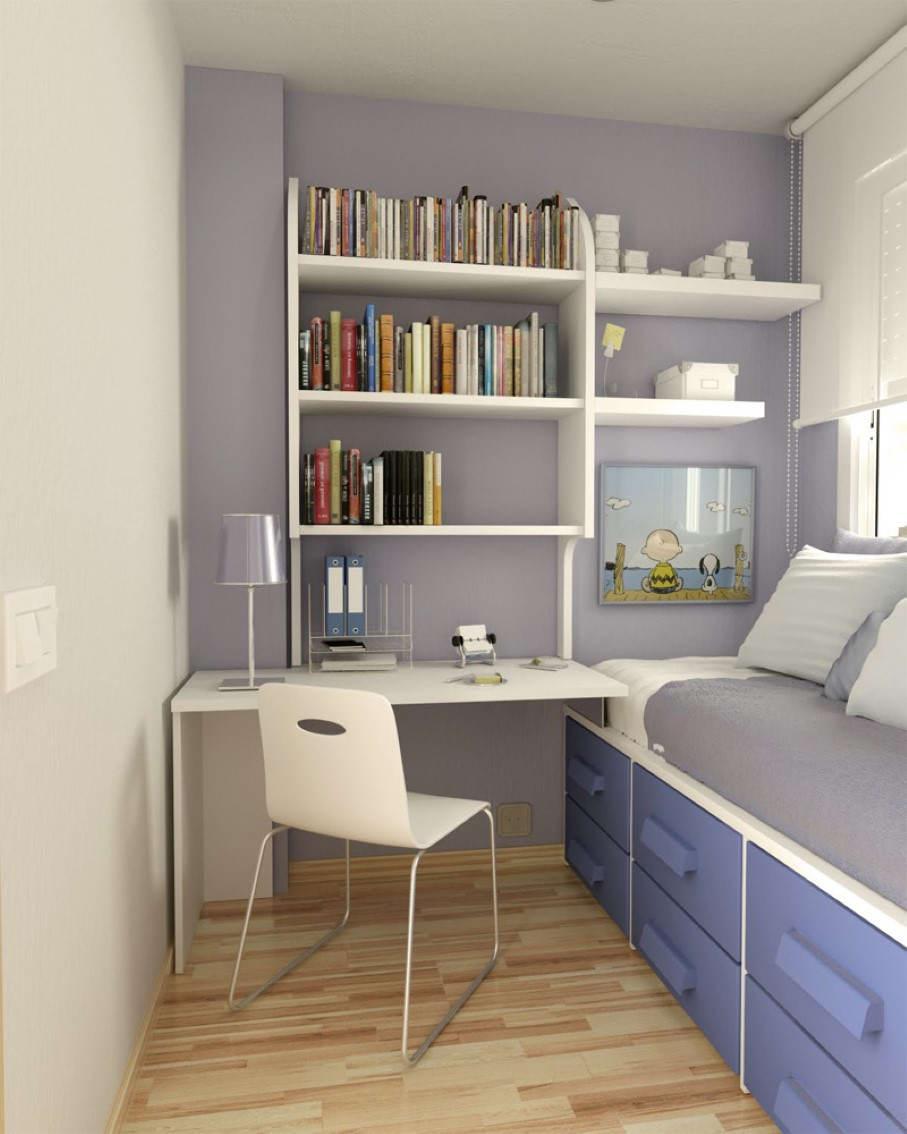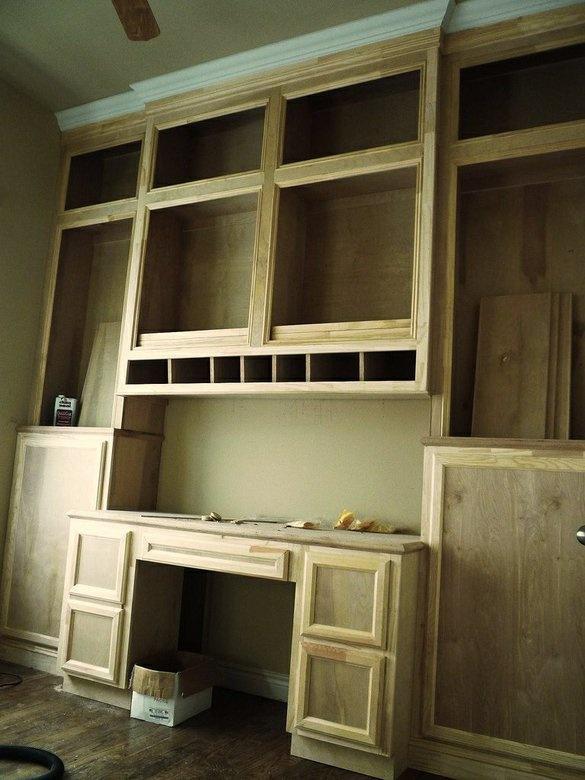The first image is the image on the left, the second image is the image on the right. Examine the images to the left and right. Is the description "In one of the images, the desk chair is white." accurate? Answer yes or no. Yes. The first image is the image on the left, the second image is the image on the right. For the images displayed, is the sentence "Both desks have a computer or monitor visible." factually correct? Answer yes or no. No. 